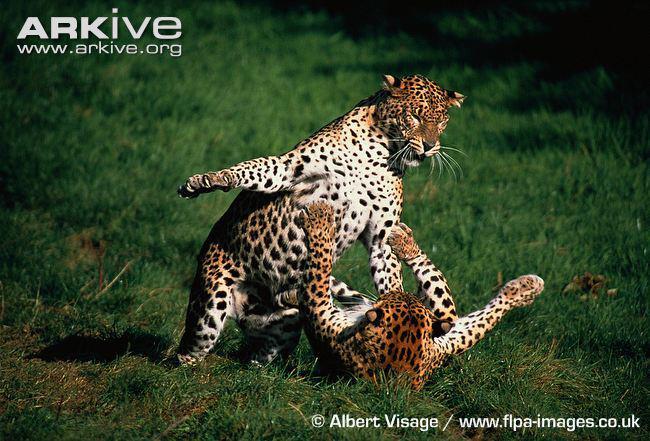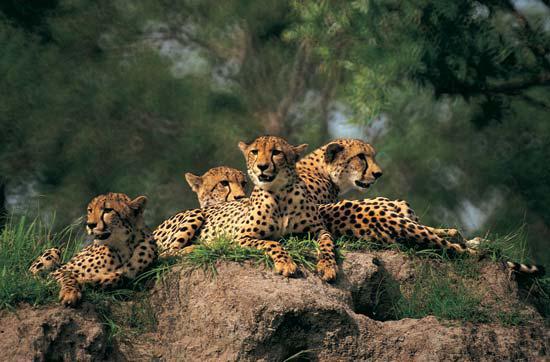The first image is the image on the left, the second image is the image on the right. For the images displayed, is the sentence "An image shows five cheetahs with their bodies similarly oriented, pointing right." factually correct? Answer yes or no. No. 